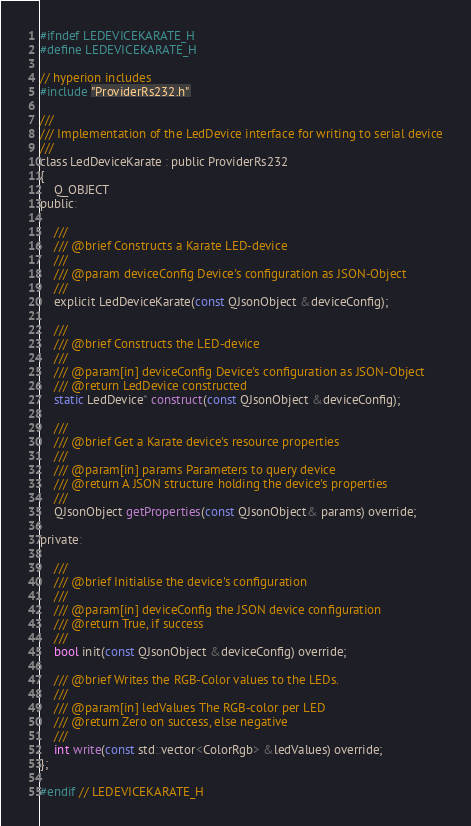<code> <loc_0><loc_0><loc_500><loc_500><_C_>#ifndef LEDEVICEKARATE_H
#define LEDEVICEKARATE_H

// hyperion includes
#include "ProviderRs232.h"

///
/// Implementation of the LedDevice interface for writing to serial device
///
class LedDeviceKarate : public ProviderRs232
{
	Q_OBJECT
public:

	///
	/// @brief Constructs a Karate LED-device
	///
	/// @param deviceConfig Device's configuration as JSON-Object
	///
	explicit LedDeviceKarate(const QJsonObject &deviceConfig);

	///
	/// @brief Constructs the LED-device
	///
	/// @param[in] deviceConfig Device's configuration as JSON-Object
	/// @return LedDevice constructed
	static LedDevice* construct(const QJsonObject &deviceConfig);

	///
	/// @brief Get a Karate device's resource properties
	///
	/// @param[in] params Parameters to query device
	/// @return A JSON structure holding the device's properties
	///
	QJsonObject getProperties(const QJsonObject& params) override;

private:

	///
	/// @brief Initialise the device's configuration
	///
	/// @param[in] deviceConfig the JSON device configuration
	/// @return True, if success
	///
	bool init(const QJsonObject &deviceConfig) override;

	/// @brief Writes the RGB-Color values to the LEDs.
	///
	/// @param[in] ledValues The RGB-color per LED
	/// @return Zero on success, else negative
	///
	int write(const std::vector<ColorRgb> &ledValues) override;
};

#endif // LEDEVICEKARATE_H
</code> 